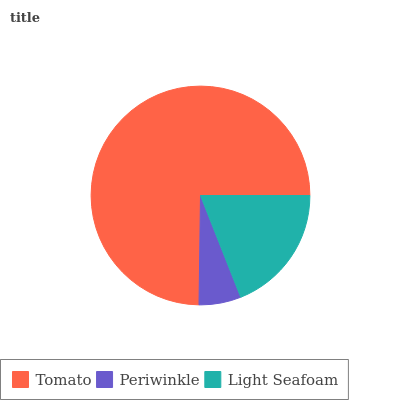Is Periwinkle the minimum?
Answer yes or no. Yes. Is Tomato the maximum?
Answer yes or no. Yes. Is Light Seafoam the minimum?
Answer yes or no. No. Is Light Seafoam the maximum?
Answer yes or no. No. Is Light Seafoam greater than Periwinkle?
Answer yes or no. Yes. Is Periwinkle less than Light Seafoam?
Answer yes or no. Yes. Is Periwinkle greater than Light Seafoam?
Answer yes or no. No. Is Light Seafoam less than Periwinkle?
Answer yes or no. No. Is Light Seafoam the high median?
Answer yes or no. Yes. Is Light Seafoam the low median?
Answer yes or no. Yes. Is Periwinkle the high median?
Answer yes or no. No. Is Tomato the low median?
Answer yes or no. No. 